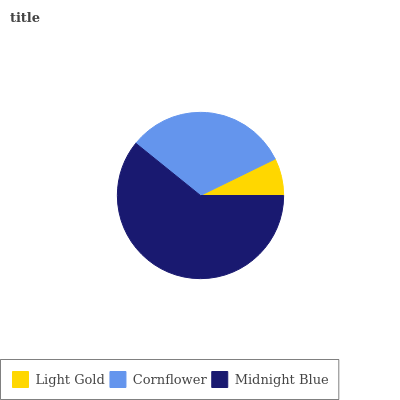Is Light Gold the minimum?
Answer yes or no. Yes. Is Midnight Blue the maximum?
Answer yes or no. Yes. Is Cornflower the minimum?
Answer yes or no. No. Is Cornflower the maximum?
Answer yes or no. No. Is Cornflower greater than Light Gold?
Answer yes or no. Yes. Is Light Gold less than Cornflower?
Answer yes or no. Yes. Is Light Gold greater than Cornflower?
Answer yes or no. No. Is Cornflower less than Light Gold?
Answer yes or no. No. Is Cornflower the high median?
Answer yes or no. Yes. Is Cornflower the low median?
Answer yes or no. Yes. Is Light Gold the high median?
Answer yes or no. No. Is Light Gold the low median?
Answer yes or no. No. 